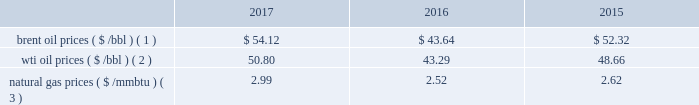Bhge 2017 form 10-k | 27 the short term .
We do , however , view the long term economics of the lng industry as positive given our outlook for supply and demand .
2022 refinery , petrochemical and industrial projects : in refining , we believe large , complex refineries should gain advantage in a more competitive , oversupplied landscape in 2018 as the industry globalizes and refiners position to meet local demand and secure export potential .
In petrochemicals , we continue to see healthy demand and cost-advantaged supply driving projects forward in 2018 .
The industrial market continues to grow as outdated infrastructure is replaced , policy changes come into effect and power is decentralized .
We continue to see growing demand across these markets in 2018 .
We have other segments in our portfolio that are more correlated with different industrial metrics such as our digital solutions business .
Overall , we believe our portfolio is uniquely positioned to compete across the value chain , and deliver unique solutions for our customers .
We remain optimistic about the long-term economics of the industry , but are continuing to operate with flexibility given our expectations for volatility and changing assumptions in the near term .
In 2016 , solar and wind net additions exceeded coal and gas for the first time and it continued throughout 2017 .
Governments may change or may not continue incentives for renewable energy additions .
In the long term , renewables' cost decline may accelerate to compete with new-built fossil capacity , however , we do not anticipate any significant impacts to our business in the foreseeable future .
Despite the near-term volatility , the long-term outlook for our industry remains strong .
We believe the world 2019s demand for energy will continue to rise , and the supply of energy will continue to increase in complexity , requiring greater service intensity and more advanced technology from oilfield service companies .
As such , we remain focused on delivering innovative cost-efficient solutions that deliver step changes in operating and economic performance for our customers .
Business environment the following discussion and analysis summarizes the significant factors affecting our results of operations , financial condition and liquidity position as of and for the year ended december 31 , 2017 , 2016 and 2015 , and should be read in conjunction with the consolidated and combined financial statements and related notes of the company .
Amounts reported in millions in graphs within this report are computed based on the amounts in hundreds .
As a result , the sum of the components reported in millions may not equal the total amount reported in millions due to rounding .
We operate in more than 120 countries helping customers find , evaluate , drill , produce , transport and process hydrocarbon resources .
Our revenue is predominately generated from the sale of products and services to major , national , and independent oil and natural gas companies worldwide , and is dependent on spending by our customers for oil and natural gas exploration , field development and production .
This spending is driven by a number of factors , including our customers' forecasts of future energy demand and supply , their access to resources to develop and produce oil and natural gas , their ability to fund their capital programs , the impact of new government regulations and most importantly , their expectations for oil and natural gas prices as a key driver of their cash flows .
Oil and natural gas prices oil and natural gas prices are summarized in the table below as averages of the daily closing prices during each of the periods indicated. .
Brent oil prices ( $ /bbl ) ( 1 ) $ 54.12 $ 43.64 $ 52.32 wti oil prices ( $ /bbl ) ( 2 ) 50.80 43.29 48.66 natural gas prices ( $ /mmbtu ) ( 3 ) 2.99 2.52 2.62 ( 1 ) energy information administration ( eia ) europe brent spot price per barrel .
What is the growth rate in wti oil prices from 2016 to 2017? 
Computations: ((50.80 - 43.29) / 43.29)
Answer: 0.17348. 